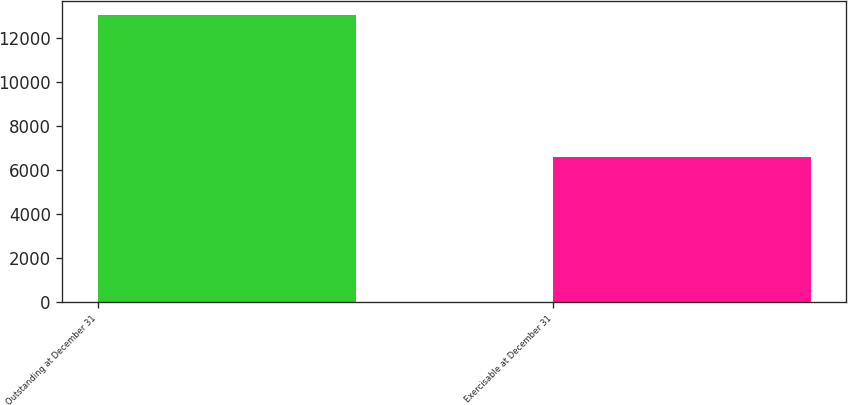Convert chart to OTSL. <chart><loc_0><loc_0><loc_500><loc_500><bar_chart><fcel>Outstanding at December 31<fcel>Exercisable at December 31<nl><fcel>13004<fcel>6609<nl></chart> 